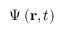<formula> <loc_0><loc_0><loc_500><loc_500>\Psi \left ( r , t \right ) \,</formula> 